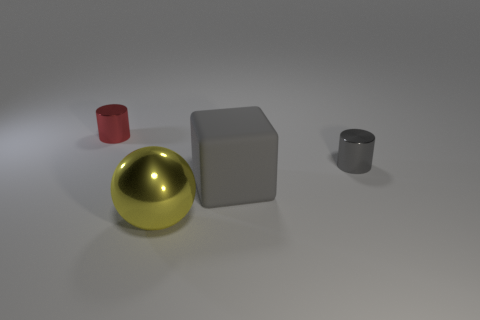Add 3 small cyan cubes. How many objects exist? 7 Subtract all blocks. How many objects are left? 3 Subtract 0 gray balls. How many objects are left? 4 Subtract all small red metallic cylinders. Subtract all big gray rubber cubes. How many objects are left? 2 Add 4 gray rubber things. How many gray rubber things are left? 5 Add 4 cyan matte cubes. How many cyan matte cubes exist? 4 